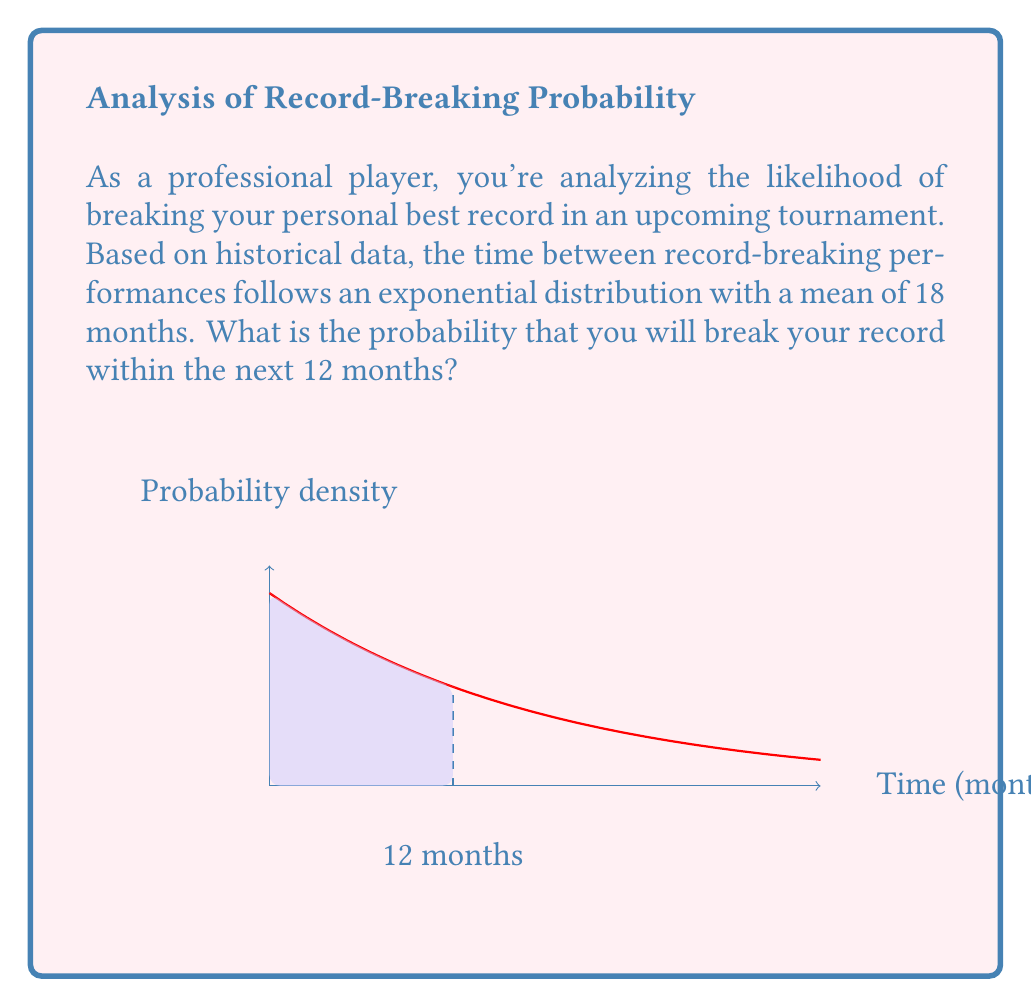Can you answer this question? Let's approach this step-by-step:

1) The exponential distribution has the probability density function:

   $$f(x) = \lambda e^{-\lambda x}$$

   where $\lambda$ is the rate parameter.

2) We're given that the mean is 18 months. For the exponential distribution, the mean is $\frac{1}{\lambda}$. So:

   $$\frac{1}{\lambda} = 18$$
   $$\lambda = \frac{1}{18}$$

3) We want to find the probability of breaking the record within 12 months. This is equivalent to finding $P(X \leq 12)$ where $X$ is the time until the next record-breaking performance.

4) For the exponential distribution, the cumulative distribution function is:

   $$P(X \leq x) = 1 - e^{-\lambda x}$$

5) Substituting our values:

   $$P(X \leq 12) = 1 - e^{-\frac{1}{18} \cdot 12}$$

6) Simplifying:

   $$P(X \leq 12) = 1 - e^{-\frac{2}{3}}$$

7) Calculating:

   $$P(X \leq 12) \approx 1 - 0.5134 = 0.4866$$

Therefore, the probability of breaking your record within the next 12 months is approximately 0.4866 or 48.66%.
Answer: $1 - e^{-\frac{2}{3}} \approx 0.4866$ 